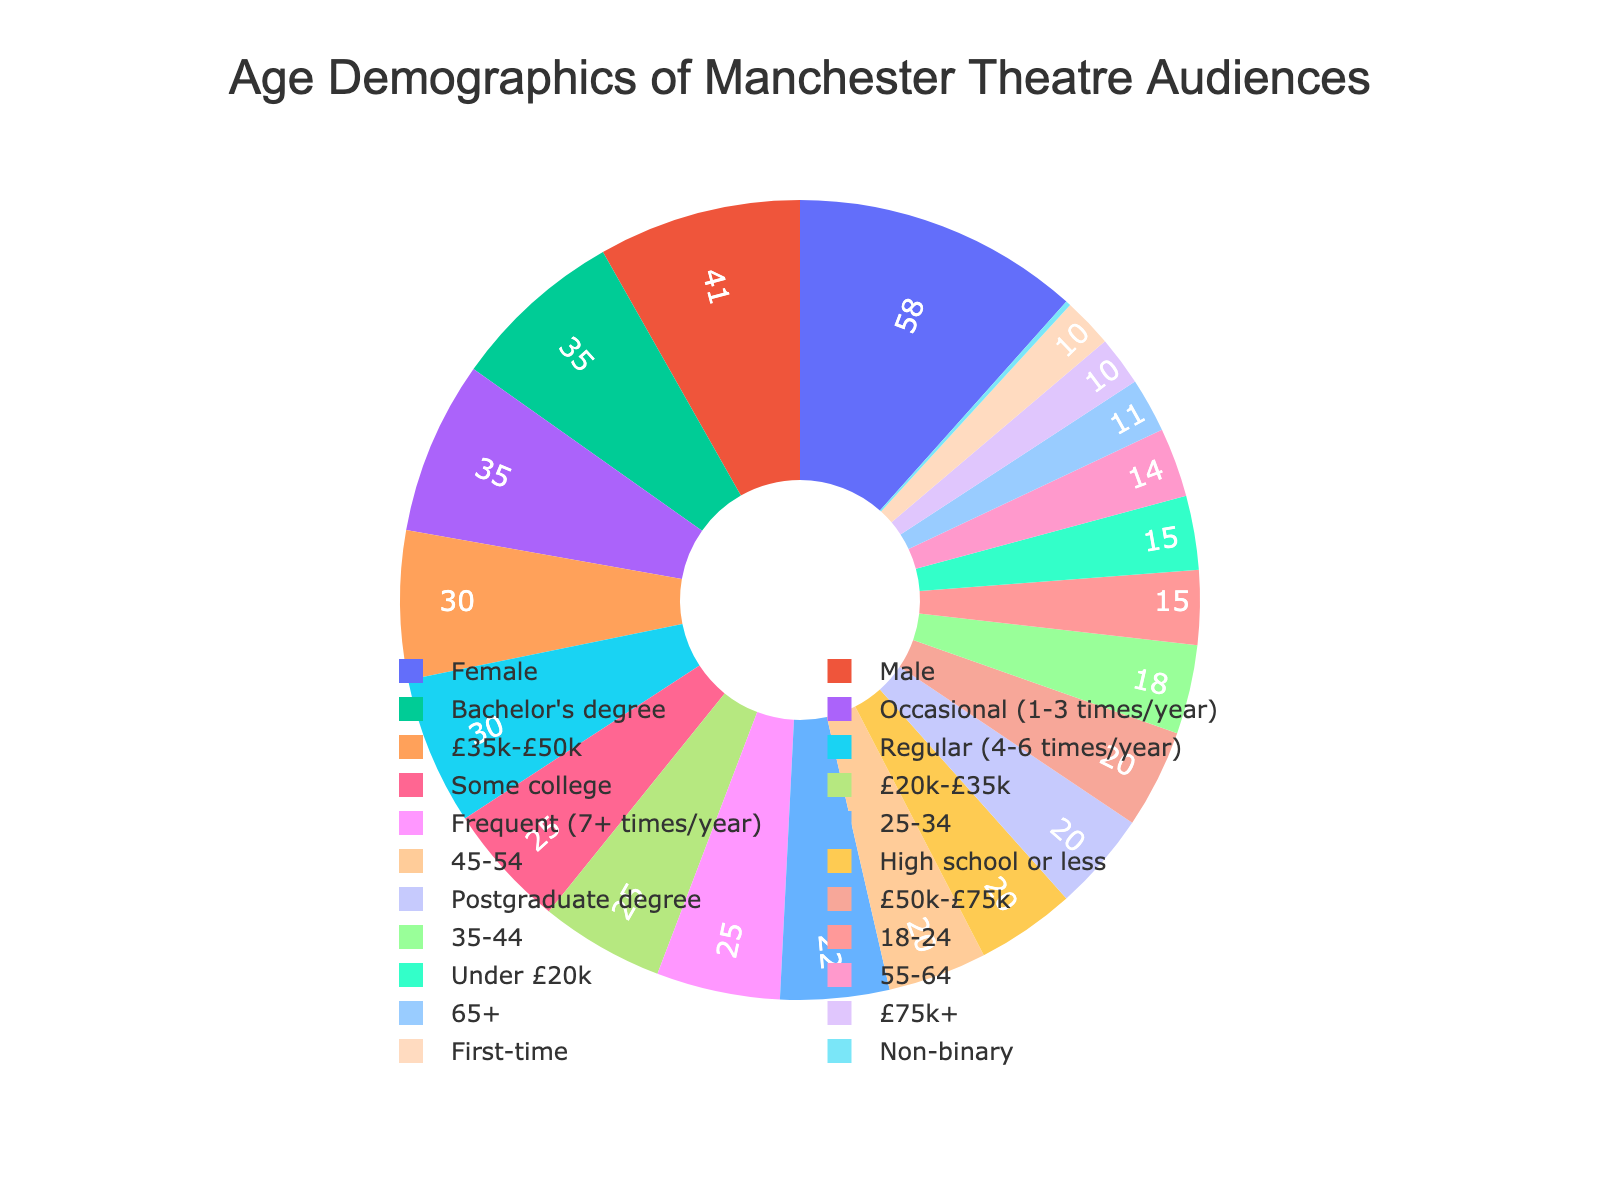What is the percentage of theatre audience members aged 25-34? Look at the pie chart segment labeled '25-34' to find its percentage.
Answer: 22% Which age group has the smallest representation in the theatre audience? Identify the segment with the smallest percentage in the pie chart. The '65+' group has the smallest representation.
Answer: 65+ How does the percentage of the '55-64' age group compare to the '18-24' age group? Compare the pie chart segments labeled '55-64' and '18-24' to see which has a higher percentage. '55-64' has a lower percentage than '18-24'.
Answer: The '55-64' age group (14%) is less than the '18-24' age group (15%) What is the sum of the percentages for the '35-44' and '45-54' age groups? Add the percentages of the '35-44' and '45-54' segments from the pie chart. 18% (35-44) + 20% (45-54) = 38%
Answer: 38% Which age group is represented by a green segment in the pie chart? Check the segment colors in the pie chart and identify which age group corresponds to green.
Answer: 35-44 What fraction of the audience is aged 35-44? Use the percentage of the '35-44' age group from the pie chart and convert it to a fraction. 18% = 18/100, which simplifies to 9/50.
Answer: 9/50 How much larger is the '25-34' percentage compared to the '65+' percentage? Subtract the '65+' percentage from the '25-34' percentage from the pie chart. 22% (25-34) - 11% (65+) = 11%
Answer: 11% What two age groups together form nearly half (close to 50%) of the audience? Identify two adjacent age groups whose percentages sum close to 50%. '25-34' (22%) and '45-54' (20%) together form 42%, which is nearly half.
Answer: 25-34 and 45-54 What percentage of the theatre audience is above 45 years old? Add the percentages of '45-54', '55-64', and '65+' segments from the pie chart. 20% (45-54) + 14% (55-64) + 11% (65+) = 45%
Answer: 45% Which two age groups combined make up less than 30% of the audience? Identify two groups whose percentages together are less than 30%. '18-24' (15%) and '65+' (11%) combined are 26%.
Answer: 18-24 and 65+ 